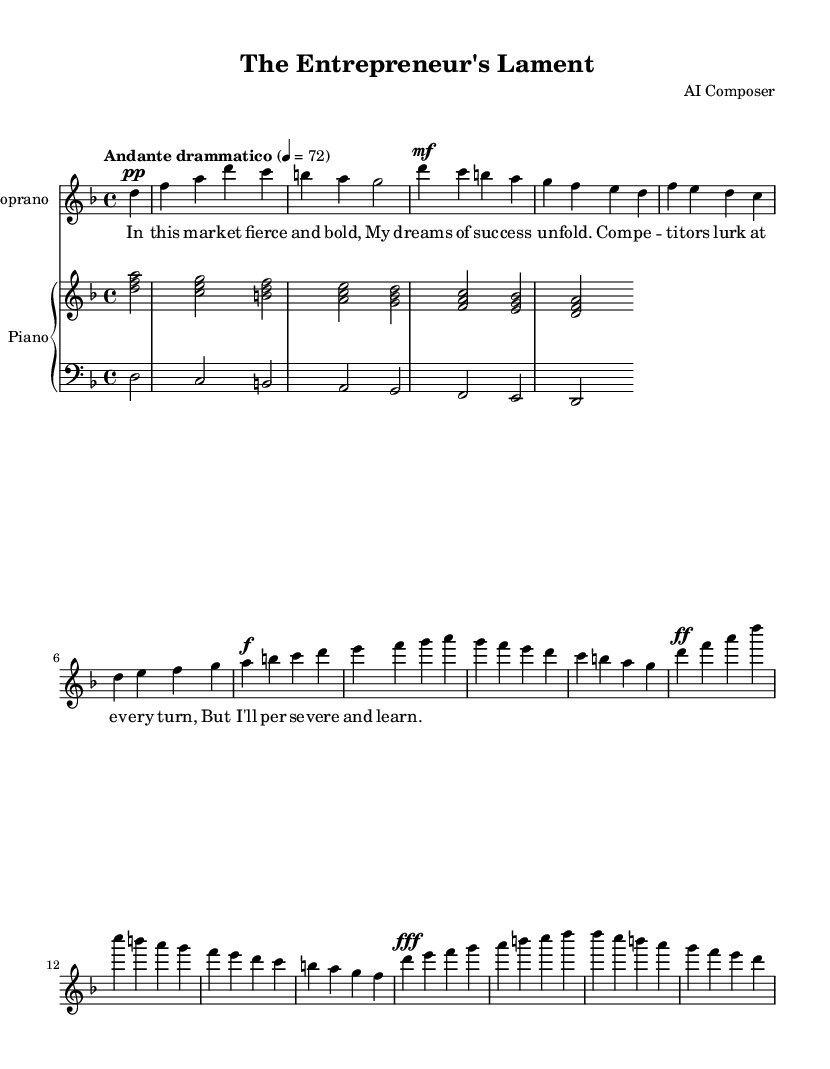What is the key signature of this music? The key signature is indicated at the beginning of the staff. It shows two flats, indicating that the piece is in D minor.
Answer: D minor What is the time signature of this piece? The time signature is specified at the beginning, written as 4 over 4, which means there are four beats in each measure.
Answer: 4/4 What is the tempo marking for this piece? The tempo is also indicated at the start of the piece, and it reads "Andante drammatico," suggesting a moderately slow and dramatic performance style.
Answer: Andante drammatico How many measures are in the soprano part? By counting the measures from the soprano section, including those with partial beats, there are a total of 16 measures.
Answer: 16 What dynamic marking appears in the last measure of the soprano part? The last measure of the soprano section includes a dynamic marking of "fff," indicating it should be played very loudly.
Answer: fff What is the primary theme expressed in the lyrics? The lyrics express the struggle and determination of an entrepreneur facing competition, emphasizing perseverance despite challenges.
Answer: Perseverance In what vocal range is this operatic piece written? The soprano part indicates a higher vocal range, starting from D and extending to a high D, which is typical for soprano voices.
Answer: Soprano 